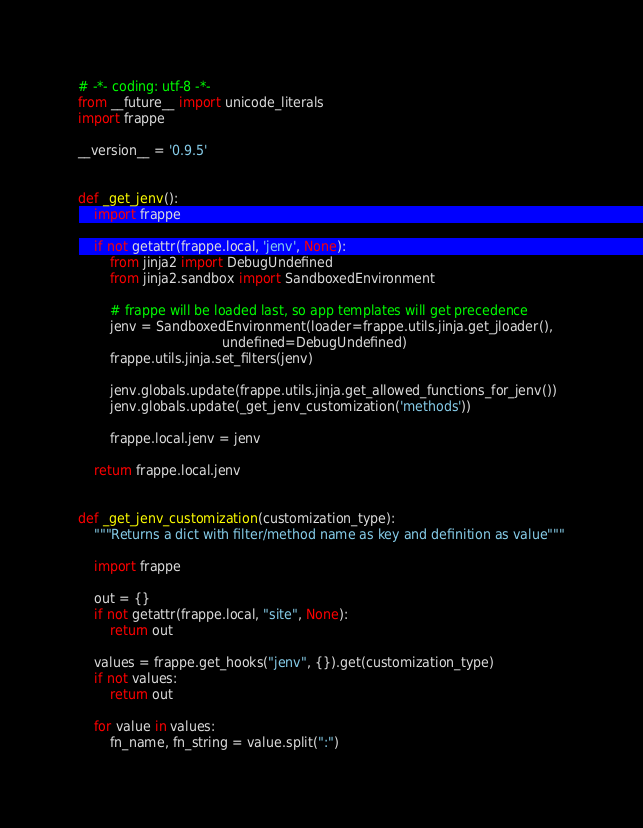<code> <loc_0><loc_0><loc_500><loc_500><_Python_># -*- coding: utf-8 -*-
from __future__ import unicode_literals
import frappe

__version__ = '0.9.5'


def _get_jenv():
    import frappe

    if not getattr(frappe.local, 'jenv', None):
        from jinja2 import DebugUndefined
        from jinja2.sandbox import SandboxedEnvironment

        # frappe will be loaded last, so app templates will get precedence
        jenv = SandboxedEnvironment(loader=frappe.utils.jinja.get_jloader(),
                                    undefined=DebugUndefined)
        frappe.utils.jinja.set_filters(jenv)

        jenv.globals.update(frappe.utils.jinja.get_allowed_functions_for_jenv())
        jenv.globals.update(_get_jenv_customization('methods'))

        frappe.local.jenv = jenv

    return frappe.local.jenv


def _get_jenv_customization(customization_type):
    """Returns a dict with filter/method name as key and definition as value"""

    import frappe

    out = {}
    if not getattr(frappe.local, "site", None):
        return out

    values = frappe.get_hooks("jenv", {}).get(customization_type)
    if not values:
        return out

    for value in values:
        fn_name, fn_string = value.split(":")</code> 